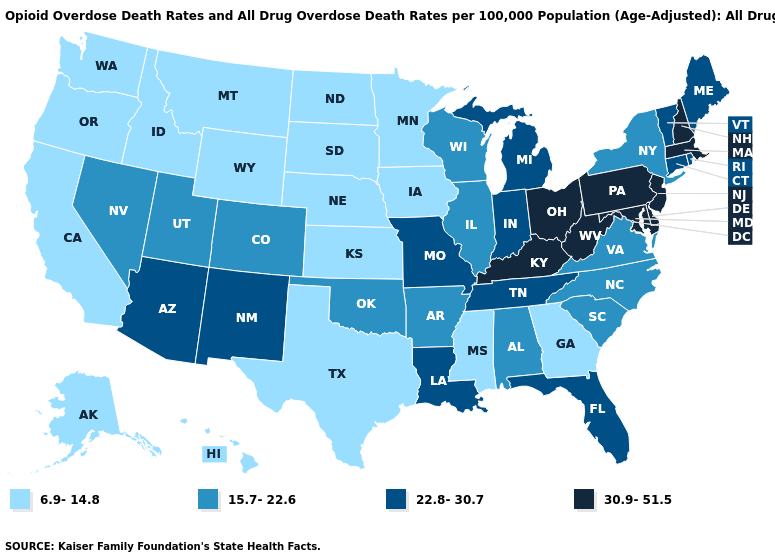Which states have the lowest value in the MidWest?
Be succinct. Iowa, Kansas, Minnesota, Nebraska, North Dakota, South Dakota. Which states have the highest value in the USA?
Answer briefly. Delaware, Kentucky, Maryland, Massachusetts, New Hampshire, New Jersey, Ohio, Pennsylvania, West Virginia. Name the states that have a value in the range 30.9-51.5?
Give a very brief answer. Delaware, Kentucky, Maryland, Massachusetts, New Hampshire, New Jersey, Ohio, Pennsylvania, West Virginia. Does Florida have the highest value in the South?
Be succinct. No. What is the value of Nevada?
Keep it brief. 15.7-22.6. What is the value of New Hampshire?
Concise answer only. 30.9-51.5. Does the map have missing data?
Short answer required. No. What is the value of Pennsylvania?
Quick response, please. 30.9-51.5. What is the value of Georgia?
Write a very short answer. 6.9-14.8. What is the value of Maryland?
Keep it brief. 30.9-51.5. What is the highest value in states that border Utah?
Answer briefly. 22.8-30.7. Does Kentucky have the highest value in the South?
Quick response, please. Yes. What is the value of Arkansas?
Concise answer only. 15.7-22.6. Does Georgia have the lowest value in the USA?
Concise answer only. Yes. What is the value of Alaska?
Be succinct. 6.9-14.8. 